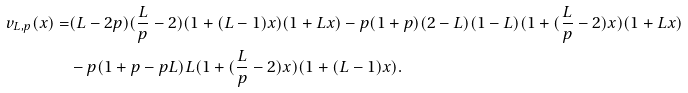Convert formula to latex. <formula><loc_0><loc_0><loc_500><loc_500>v _ { L , p } ( x ) = & ( L - 2 p ) ( \frac { L } { p } - 2 ) ( 1 + ( L - 1 ) x ) ( 1 + L x ) - p ( 1 + p ) ( 2 - L ) ( 1 - L ) ( 1 + ( \frac { L } { p } - 2 ) x ) ( 1 + L x ) \\ & - p ( 1 + p - p L ) L ( 1 + ( \frac { L } { p } - 2 ) x ) ( 1 + ( L - 1 ) x ) .</formula> 